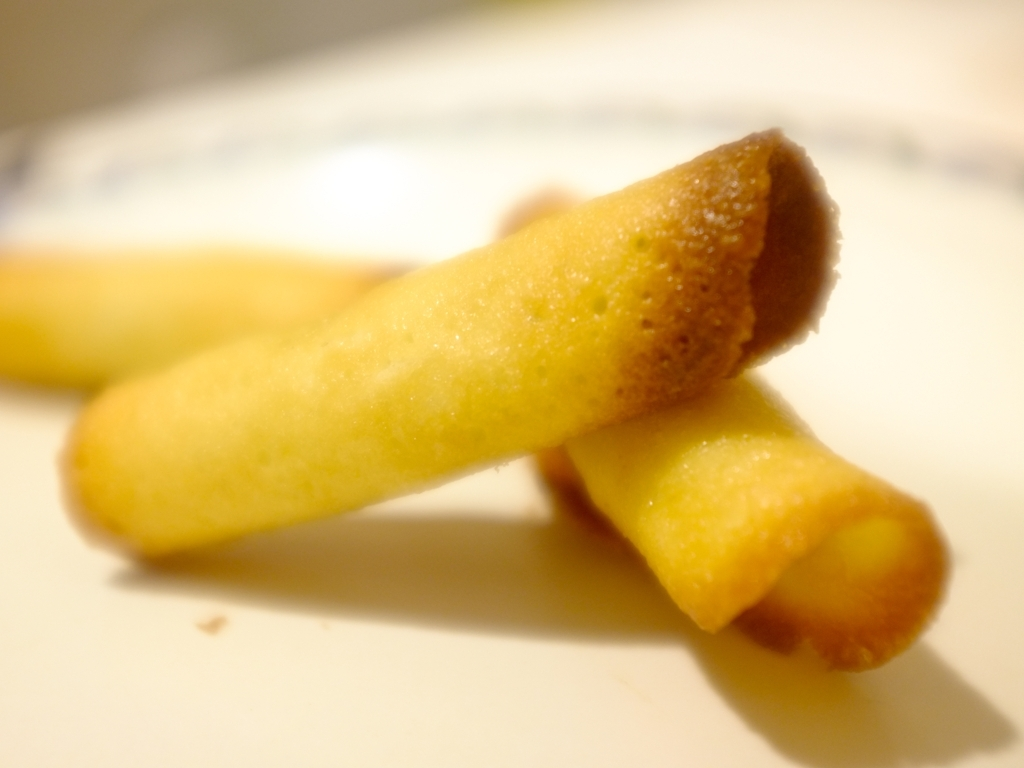What kind of food is shown in the picture? The picture appears to show a sweet snack, likely some kind of rolled wafer or cookie. Its golden-brown color and tubular shape are characteristic of such desserts. What might be the texture of this food? Given its appearance, the texture of the food is probably crisp and crunchy on the outside, with a lighter, perhaps airy interior. Such snacks are often enjoyed for their delicate crunch. 